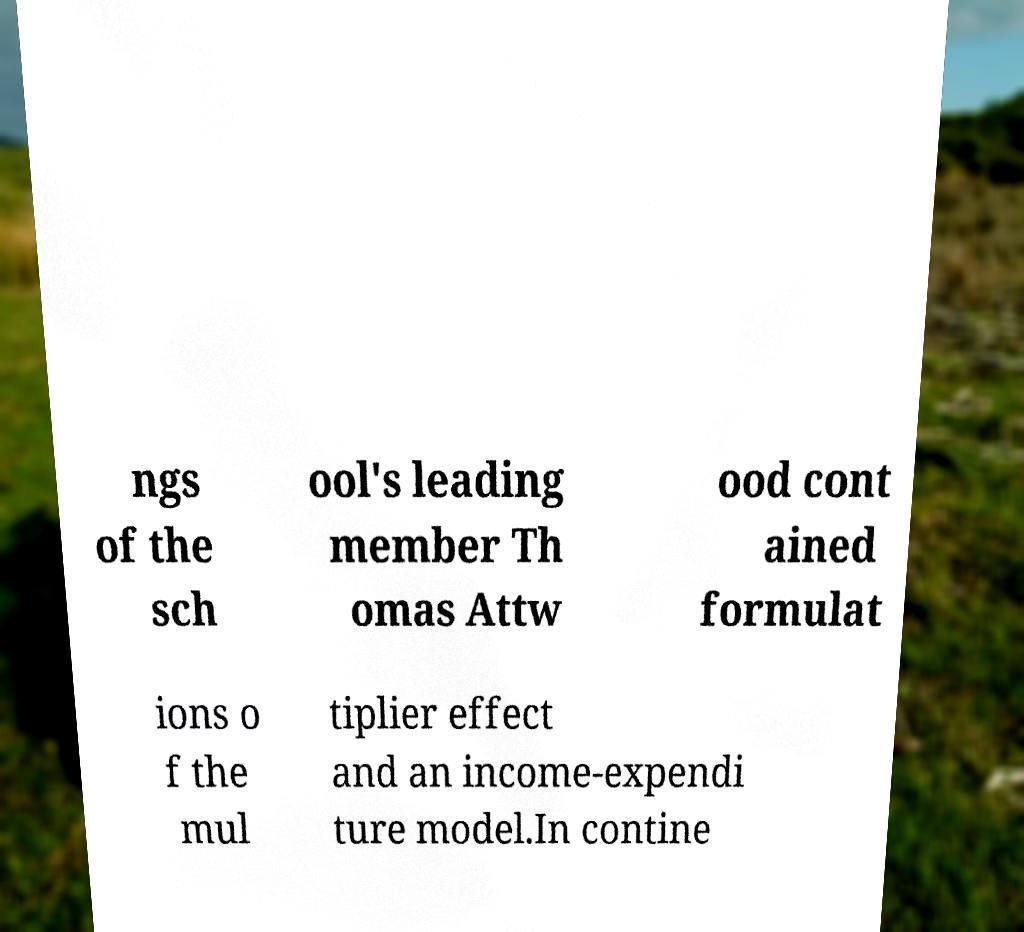Can you accurately transcribe the text from the provided image for me? ngs of the sch ool's leading member Th omas Attw ood cont ained formulat ions o f the mul tiplier effect and an income-expendi ture model.In contine 